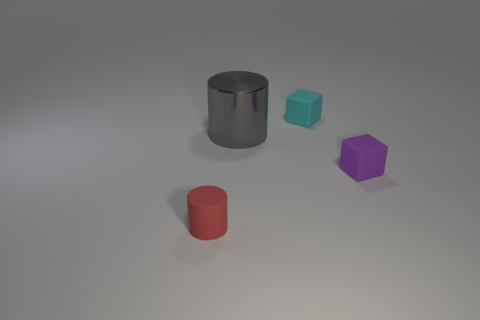Add 1 small rubber things. How many objects exist? 5 Add 1 tiny cyan matte things. How many tiny cyan matte things are left? 2 Add 3 purple rubber blocks. How many purple rubber blocks exist? 4 Subtract 0 cyan cylinders. How many objects are left? 4 Subtract all tiny yellow shiny spheres. Subtract all blocks. How many objects are left? 2 